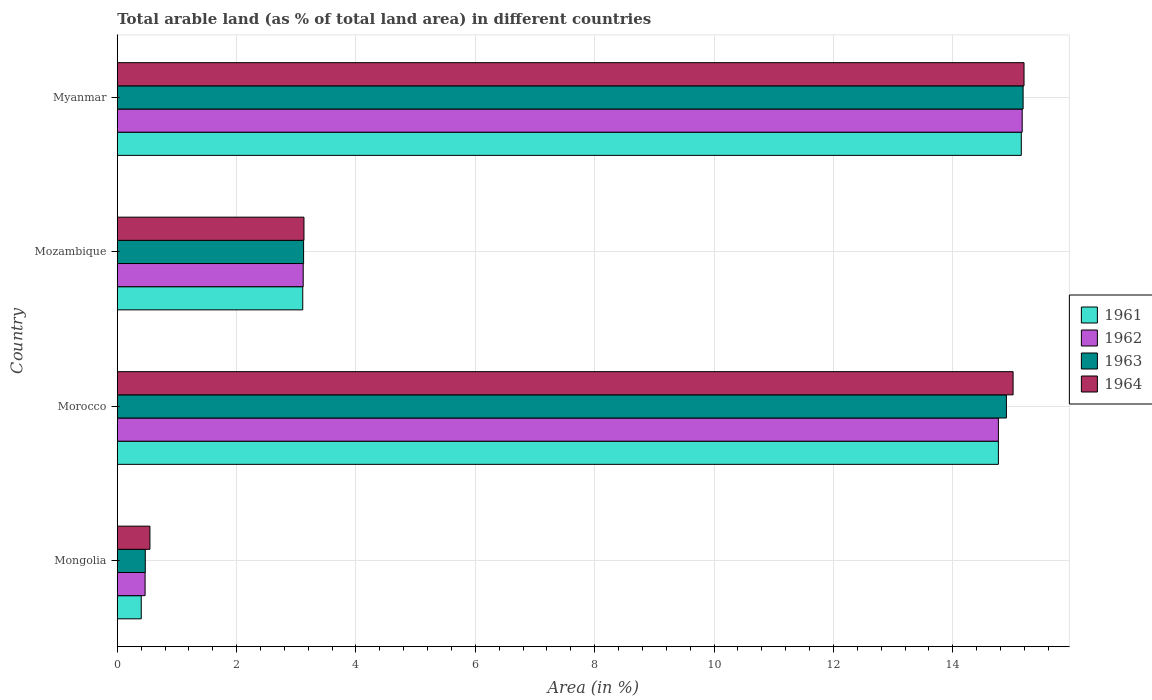Are the number of bars per tick equal to the number of legend labels?
Your answer should be compact. Yes. What is the label of the 3rd group of bars from the top?
Keep it short and to the point. Morocco. What is the percentage of arable land in 1963 in Morocco?
Ensure brevity in your answer.  14.9. Across all countries, what is the maximum percentage of arable land in 1961?
Keep it short and to the point. 15.15. Across all countries, what is the minimum percentage of arable land in 1961?
Provide a succinct answer. 0.4. In which country was the percentage of arable land in 1963 maximum?
Your answer should be very brief. Myanmar. In which country was the percentage of arable land in 1964 minimum?
Offer a terse response. Mongolia. What is the total percentage of arable land in 1962 in the graph?
Make the answer very short. 33.51. What is the difference between the percentage of arable land in 1963 in Mozambique and that in Myanmar?
Your response must be concise. -12.06. What is the difference between the percentage of arable land in 1964 in Mozambique and the percentage of arable land in 1962 in Myanmar?
Your answer should be very brief. -12.04. What is the average percentage of arable land in 1964 per country?
Provide a succinct answer. 8.47. What is the difference between the percentage of arable land in 1962 and percentage of arable land in 1961 in Morocco?
Your response must be concise. 0. What is the ratio of the percentage of arable land in 1962 in Mongolia to that in Morocco?
Offer a very short reply. 0.03. Is the difference between the percentage of arable land in 1962 in Morocco and Mozambique greater than the difference between the percentage of arable land in 1961 in Morocco and Mozambique?
Give a very brief answer. No. What is the difference between the highest and the second highest percentage of arable land in 1964?
Make the answer very short. 0.18. What is the difference between the highest and the lowest percentage of arable land in 1961?
Ensure brevity in your answer.  14.75. In how many countries, is the percentage of arable land in 1963 greater than the average percentage of arable land in 1963 taken over all countries?
Your answer should be very brief. 2. What does the 4th bar from the top in Myanmar represents?
Keep it short and to the point. 1961. How many countries are there in the graph?
Make the answer very short. 4. What is the difference between two consecutive major ticks on the X-axis?
Make the answer very short. 2. Are the values on the major ticks of X-axis written in scientific E-notation?
Make the answer very short. No. Does the graph contain grids?
Ensure brevity in your answer.  Yes. How many legend labels are there?
Your response must be concise. 4. How are the legend labels stacked?
Your answer should be very brief. Vertical. What is the title of the graph?
Your response must be concise. Total arable land (as % of total land area) in different countries. Does "2008" appear as one of the legend labels in the graph?
Your answer should be compact. No. What is the label or title of the X-axis?
Give a very brief answer. Area (in %). What is the Area (in %) of 1961 in Mongolia?
Ensure brevity in your answer.  0.4. What is the Area (in %) of 1962 in Mongolia?
Offer a terse response. 0.47. What is the Area (in %) in 1963 in Mongolia?
Make the answer very short. 0.47. What is the Area (in %) in 1964 in Mongolia?
Your answer should be compact. 0.55. What is the Area (in %) in 1961 in Morocco?
Offer a very short reply. 14.76. What is the Area (in %) in 1962 in Morocco?
Provide a short and direct response. 14.76. What is the Area (in %) of 1963 in Morocco?
Offer a very short reply. 14.9. What is the Area (in %) in 1964 in Morocco?
Offer a very short reply. 15.01. What is the Area (in %) of 1961 in Mozambique?
Offer a very short reply. 3.11. What is the Area (in %) in 1962 in Mozambique?
Your answer should be compact. 3.12. What is the Area (in %) in 1963 in Mozambique?
Your answer should be very brief. 3.12. What is the Area (in %) of 1964 in Mozambique?
Offer a very short reply. 3.13. What is the Area (in %) of 1961 in Myanmar?
Provide a short and direct response. 15.15. What is the Area (in %) in 1962 in Myanmar?
Your answer should be compact. 15.16. What is the Area (in %) of 1963 in Myanmar?
Ensure brevity in your answer.  15.18. What is the Area (in %) in 1964 in Myanmar?
Offer a very short reply. 15.19. Across all countries, what is the maximum Area (in %) of 1961?
Your answer should be compact. 15.15. Across all countries, what is the maximum Area (in %) in 1962?
Give a very brief answer. 15.16. Across all countries, what is the maximum Area (in %) of 1963?
Provide a succinct answer. 15.18. Across all countries, what is the maximum Area (in %) in 1964?
Make the answer very short. 15.19. Across all countries, what is the minimum Area (in %) in 1961?
Provide a short and direct response. 0.4. Across all countries, what is the minimum Area (in %) of 1962?
Provide a succinct answer. 0.47. Across all countries, what is the minimum Area (in %) of 1963?
Offer a terse response. 0.47. Across all countries, what is the minimum Area (in %) of 1964?
Offer a very short reply. 0.55. What is the total Area (in %) in 1961 in the graph?
Your answer should be very brief. 33.42. What is the total Area (in %) in 1962 in the graph?
Make the answer very short. 33.51. What is the total Area (in %) of 1963 in the graph?
Offer a very short reply. 33.67. What is the total Area (in %) of 1964 in the graph?
Provide a succinct answer. 33.88. What is the difference between the Area (in %) in 1961 in Mongolia and that in Morocco?
Your answer should be very brief. -14.36. What is the difference between the Area (in %) of 1962 in Mongolia and that in Morocco?
Ensure brevity in your answer.  -14.3. What is the difference between the Area (in %) in 1963 in Mongolia and that in Morocco?
Offer a terse response. -14.43. What is the difference between the Area (in %) in 1964 in Mongolia and that in Morocco?
Give a very brief answer. -14.46. What is the difference between the Area (in %) in 1961 in Mongolia and that in Mozambique?
Give a very brief answer. -2.71. What is the difference between the Area (in %) of 1962 in Mongolia and that in Mozambique?
Keep it short and to the point. -2.65. What is the difference between the Area (in %) of 1963 in Mongolia and that in Mozambique?
Give a very brief answer. -2.65. What is the difference between the Area (in %) of 1964 in Mongolia and that in Mozambique?
Your answer should be very brief. -2.58. What is the difference between the Area (in %) in 1961 in Mongolia and that in Myanmar?
Your response must be concise. -14.75. What is the difference between the Area (in %) of 1962 in Mongolia and that in Myanmar?
Offer a very short reply. -14.7. What is the difference between the Area (in %) in 1963 in Mongolia and that in Myanmar?
Your answer should be very brief. -14.71. What is the difference between the Area (in %) in 1964 in Mongolia and that in Myanmar?
Provide a succinct answer. -14.65. What is the difference between the Area (in %) of 1961 in Morocco and that in Mozambique?
Your answer should be compact. 11.66. What is the difference between the Area (in %) in 1962 in Morocco and that in Mozambique?
Make the answer very short. 11.65. What is the difference between the Area (in %) in 1963 in Morocco and that in Mozambique?
Keep it short and to the point. 11.78. What is the difference between the Area (in %) of 1964 in Morocco and that in Mozambique?
Provide a succinct answer. 11.88. What is the difference between the Area (in %) of 1961 in Morocco and that in Myanmar?
Give a very brief answer. -0.38. What is the difference between the Area (in %) in 1962 in Morocco and that in Myanmar?
Offer a terse response. -0.4. What is the difference between the Area (in %) of 1963 in Morocco and that in Myanmar?
Offer a very short reply. -0.28. What is the difference between the Area (in %) of 1964 in Morocco and that in Myanmar?
Keep it short and to the point. -0.18. What is the difference between the Area (in %) in 1961 in Mozambique and that in Myanmar?
Provide a succinct answer. -12.04. What is the difference between the Area (in %) of 1962 in Mozambique and that in Myanmar?
Make the answer very short. -12.05. What is the difference between the Area (in %) in 1963 in Mozambique and that in Myanmar?
Make the answer very short. -12.06. What is the difference between the Area (in %) in 1964 in Mozambique and that in Myanmar?
Your answer should be very brief. -12.07. What is the difference between the Area (in %) of 1961 in Mongolia and the Area (in %) of 1962 in Morocco?
Provide a succinct answer. -14.36. What is the difference between the Area (in %) in 1961 in Mongolia and the Area (in %) in 1963 in Morocco?
Make the answer very short. -14.5. What is the difference between the Area (in %) of 1961 in Mongolia and the Area (in %) of 1964 in Morocco?
Offer a terse response. -14.61. What is the difference between the Area (in %) of 1962 in Mongolia and the Area (in %) of 1963 in Morocco?
Provide a succinct answer. -14.43. What is the difference between the Area (in %) in 1962 in Mongolia and the Area (in %) in 1964 in Morocco?
Keep it short and to the point. -14.54. What is the difference between the Area (in %) in 1963 in Mongolia and the Area (in %) in 1964 in Morocco?
Your answer should be compact. -14.54. What is the difference between the Area (in %) of 1961 in Mongolia and the Area (in %) of 1962 in Mozambique?
Your response must be concise. -2.71. What is the difference between the Area (in %) of 1961 in Mongolia and the Area (in %) of 1963 in Mozambique?
Offer a very short reply. -2.72. What is the difference between the Area (in %) in 1961 in Mongolia and the Area (in %) in 1964 in Mozambique?
Offer a terse response. -2.73. What is the difference between the Area (in %) in 1962 in Mongolia and the Area (in %) in 1963 in Mozambique?
Make the answer very short. -2.66. What is the difference between the Area (in %) in 1962 in Mongolia and the Area (in %) in 1964 in Mozambique?
Ensure brevity in your answer.  -2.66. What is the difference between the Area (in %) of 1963 in Mongolia and the Area (in %) of 1964 in Mozambique?
Offer a terse response. -2.66. What is the difference between the Area (in %) of 1961 in Mongolia and the Area (in %) of 1962 in Myanmar?
Provide a short and direct response. -14.76. What is the difference between the Area (in %) in 1961 in Mongolia and the Area (in %) in 1963 in Myanmar?
Offer a terse response. -14.78. What is the difference between the Area (in %) in 1961 in Mongolia and the Area (in %) in 1964 in Myanmar?
Your answer should be compact. -14.79. What is the difference between the Area (in %) in 1962 in Mongolia and the Area (in %) in 1963 in Myanmar?
Offer a very short reply. -14.71. What is the difference between the Area (in %) in 1962 in Mongolia and the Area (in %) in 1964 in Myanmar?
Give a very brief answer. -14.73. What is the difference between the Area (in %) in 1963 in Mongolia and the Area (in %) in 1964 in Myanmar?
Offer a very short reply. -14.72. What is the difference between the Area (in %) of 1961 in Morocco and the Area (in %) of 1962 in Mozambique?
Keep it short and to the point. 11.65. What is the difference between the Area (in %) of 1961 in Morocco and the Area (in %) of 1963 in Mozambique?
Your response must be concise. 11.64. What is the difference between the Area (in %) of 1961 in Morocco and the Area (in %) of 1964 in Mozambique?
Offer a terse response. 11.64. What is the difference between the Area (in %) of 1962 in Morocco and the Area (in %) of 1963 in Mozambique?
Your answer should be compact. 11.64. What is the difference between the Area (in %) of 1962 in Morocco and the Area (in %) of 1964 in Mozambique?
Make the answer very short. 11.64. What is the difference between the Area (in %) of 1963 in Morocco and the Area (in %) of 1964 in Mozambique?
Keep it short and to the point. 11.77. What is the difference between the Area (in %) of 1961 in Morocco and the Area (in %) of 1962 in Myanmar?
Give a very brief answer. -0.4. What is the difference between the Area (in %) in 1961 in Morocco and the Area (in %) in 1963 in Myanmar?
Make the answer very short. -0.41. What is the difference between the Area (in %) of 1961 in Morocco and the Area (in %) of 1964 in Myanmar?
Ensure brevity in your answer.  -0.43. What is the difference between the Area (in %) in 1962 in Morocco and the Area (in %) in 1963 in Myanmar?
Your response must be concise. -0.41. What is the difference between the Area (in %) in 1962 in Morocco and the Area (in %) in 1964 in Myanmar?
Your response must be concise. -0.43. What is the difference between the Area (in %) in 1963 in Morocco and the Area (in %) in 1964 in Myanmar?
Give a very brief answer. -0.3. What is the difference between the Area (in %) in 1961 in Mozambique and the Area (in %) in 1962 in Myanmar?
Offer a terse response. -12.06. What is the difference between the Area (in %) in 1961 in Mozambique and the Area (in %) in 1963 in Myanmar?
Give a very brief answer. -12.07. What is the difference between the Area (in %) of 1961 in Mozambique and the Area (in %) of 1964 in Myanmar?
Keep it short and to the point. -12.09. What is the difference between the Area (in %) of 1962 in Mozambique and the Area (in %) of 1963 in Myanmar?
Your response must be concise. -12.06. What is the difference between the Area (in %) of 1962 in Mozambique and the Area (in %) of 1964 in Myanmar?
Your response must be concise. -12.08. What is the difference between the Area (in %) in 1963 in Mozambique and the Area (in %) in 1964 in Myanmar?
Keep it short and to the point. -12.07. What is the average Area (in %) of 1961 per country?
Offer a terse response. 8.36. What is the average Area (in %) of 1962 per country?
Provide a succinct answer. 8.38. What is the average Area (in %) of 1963 per country?
Your response must be concise. 8.42. What is the average Area (in %) in 1964 per country?
Provide a succinct answer. 8.47. What is the difference between the Area (in %) in 1961 and Area (in %) in 1962 in Mongolia?
Keep it short and to the point. -0.06. What is the difference between the Area (in %) of 1961 and Area (in %) of 1963 in Mongolia?
Your answer should be very brief. -0.07. What is the difference between the Area (in %) in 1961 and Area (in %) in 1964 in Mongolia?
Make the answer very short. -0.15. What is the difference between the Area (in %) of 1962 and Area (in %) of 1963 in Mongolia?
Your answer should be compact. -0. What is the difference between the Area (in %) in 1962 and Area (in %) in 1964 in Mongolia?
Provide a succinct answer. -0.08. What is the difference between the Area (in %) in 1963 and Area (in %) in 1964 in Mongolia?
Your answer should be very brief. -0.08. What is the difference between the Area (in %) in 1961 and Area (in %) in 1962 in Morocco?
Provide a short and direct response. 0. What is the difference between the Area (in %) in 1961 and Area (in %) in 1963 in Morocco?
Ensure brevity in your answer.  -0.13. What is the difference between the Area (in %) of 1961 and Area (in %) of 1964 in Morocco?
Offer a very short reply. -0.25. What is the difference between the Area (in %) in 1962 and Area (in %) in 1963 in Morocco?
Offer a very short reply. -0.13. What is the difference between the Area (in %) of 1962 and Area (in %) of 1964 in Morocco?
Offer a very short reply. -0.25. What is the difference between the Area (in %) in 1963 and Area (in %) in 1964 in Morocco?
Your answer should be compact. -0.11. What is the difference between the Area (in %) of 1961 and Area (in %) of 1962 in Mozambique?
Your answer should be very brief. -0.01. What is the difference between the Area (in %) of 1961 and Area (in %) of 1963 in Mozambique?
Provide a succinct answer. -0.01. What is the difference between the Area (in %) of 1961 and Area (in %) of 1964 in Mozambique?
Your answer should be very brief. -0.02. What is the difference between the Area (in %) in 1962 and Area (in %) in 1963 in Mozambique?
Ensure brevity in your answer.  -0.01. What is the difference between the Area (in %) in 1962 and Area (in %) in 1964 in Mozambique?
Your answer should be very brief. -0.01. What is the difference between the Area (in %) in 1963 and Area (in %) in 1964 in Mozambique?
Your response must be concise. -0.01. What is the difference between the Area (in %) in 1961 and Area (in %) in 1962 in Myanmar?
Your answer should be compact. -0.02. What is the difference between the Area (in %) of 1961 and Area (in %) of 1963 in Myanmar?
Provide a succinct answer. -0.03. What is the difference between the Area (in %) of 1961 and Area (in %) of 1964 in Myanmar?
Keep it short and to the point. -0.05. What is the difference between the Area (in %) of 1962 and Area (in %) of 1963 in Myanmar?
Make the answer very short. -0.02. What is the difference between the Area (in %) in 1962 and Area (in %) in 1964 in Myanmar?
Provide a short and direct response. -0.03. What is the difference between the Area (in %) in 1963 and Area (in %) in 1964 in Myanmar?
Make the answer very short. -0.02. What is the ratio of the Area (in %) of 1961 in Mongolia to that in Morocco?
Offer a very short reply. 0.03. What is the ratio of the Area (in %) of 1962 in Mongolia to that in Morocco?
Offer a terse response. 0.03. What is the ratio of the Area (in %) of 1963 in Mongolia to that in Morocco?
Offer a terse response. 0.03. What is the ratio of the Area (in %) in 1964 in Mongolia to that in Morocco?
Offer a terse response. 0.04. What is the ratio of the Area (in %) of 1961 in Mongolia to that in Mozambique?
Your answer should be compact. 0.13. What is the ratio of the Area (in %) of 1962 in Mongolia to that in Mozambique?
Make the answer very short. 0.15. What is the ratio of the Area (in %) in 1963 in Mongolia to that in Mozambique?
Ensure brevity in your answer.  0.15. What is the ratio of the Area (in %) of 1964 in Mongolia to that in Mozambique?
Offer a very short reply. 0.17. What is the ratio of the Area (in %) of 1961 in Mongolia to that in Myanmar?
Keep it short and to the point. 0.03. What is the ratio of the Area (in %) in 1962 in Mongolia to that in Myanmar?
Provide a succinct answer. 0.03. What is the ratio of the Area (in %) of 1963 in Mongolia to that in Myanmar?
Give a very brief answer. 0.03. What is the ratio of the Area (in %) in 1964 in Mongolia to that in Myanmar?
Offer a terse response. 0.04. What is the ratio of the Area (in %) of 1961 in Morocco to that in Mozambique?
Provide a succinct answer. 4.75. What is the ratio of the Area (in %) in 1962 in Morocco to that in Mozambique?
Ensure brevity in your answer.  4.74. What is the ratio of the Area (in %) in 1963 in Morocco to that in Mozambique?
Make the answer very short. 4.77. What is the ratio of the Area (in %) of 1964 in Morocco to that in Mozambique?
Provide a short and direct response. 4.8. What is the ratio of the Area (in %) of 1961 in Morocco to that in Myanmar?
Provide a short and direct response. 0.97. What is the ratio of the Area (in %) in 1962 in Morocco to that in Myanmar?
Your answer should be compact. 0.97. What is the ratio of the Area (in %) in 1963 in Morocco to that in Myanmar?
Give a very brief answer. 0.98. What is the ratio of the Area (in %) of 1964 in Morocco to that in Myanmar?
Give a very brief answer. 0.99. What is the ratio of the Area (in %) of 1961 in Mozambique to that in Myanmar?
Offer a terse response. 0.21. What is the ratio of the Area (in %) in 1962 in Mozambique to that in Myanmar?
Provide a succinct answer. 0.21. What is the ratio of the Area (in %) in 1963 in Mozambique to that in Myanmar?
Ensure brevity in your answer.  0.21. What is the ratio of the Area (in %) in 1964 in Mozambique to that in Myanmar?
Offer a very short reply. 0.21. What is the difference between the highest and the second highest Area (in %) of 1961?
Provide a short and direct response. 0.38. What is the difference between the highest and the second highest Area (in %) in 1962?
Your answer should be very brief. 0.4. What is the difference between the highest and the second highest Area (in %) of 1963?
Ensure brevity in your answer.  0.28. What is the difference between the highest and the second highest Area (in %) in 1964?
Provide a short and direct response. 0.18. What is the difference between the highest and the lowest Area (in %) of 1961?
Offer a very short reply. 14.75. What is the difference between the highest and the lowest Area (in %) in 1962?
Your answer should be very brief. 14.7. What is the difference between the highest and the lowest Area (in %) of 1963?
Your answer should be very brief. 14.71. What is the difference between the highest and the lowest Area (in %) of 1964?
Your answer should be compact. 14.65. 